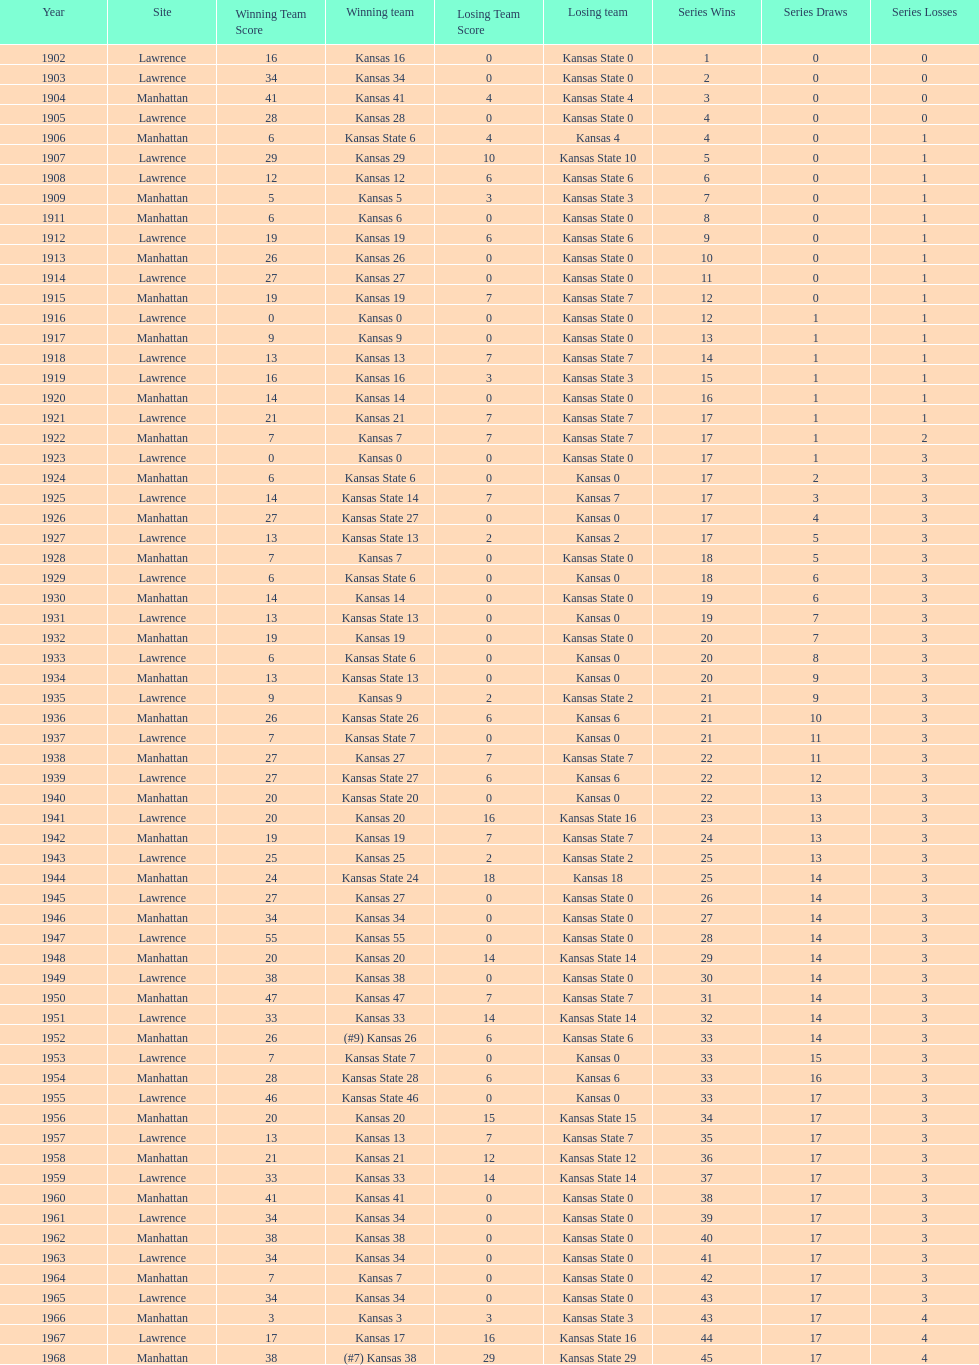How many times did kansas beat kansas state before 1910? 7. 